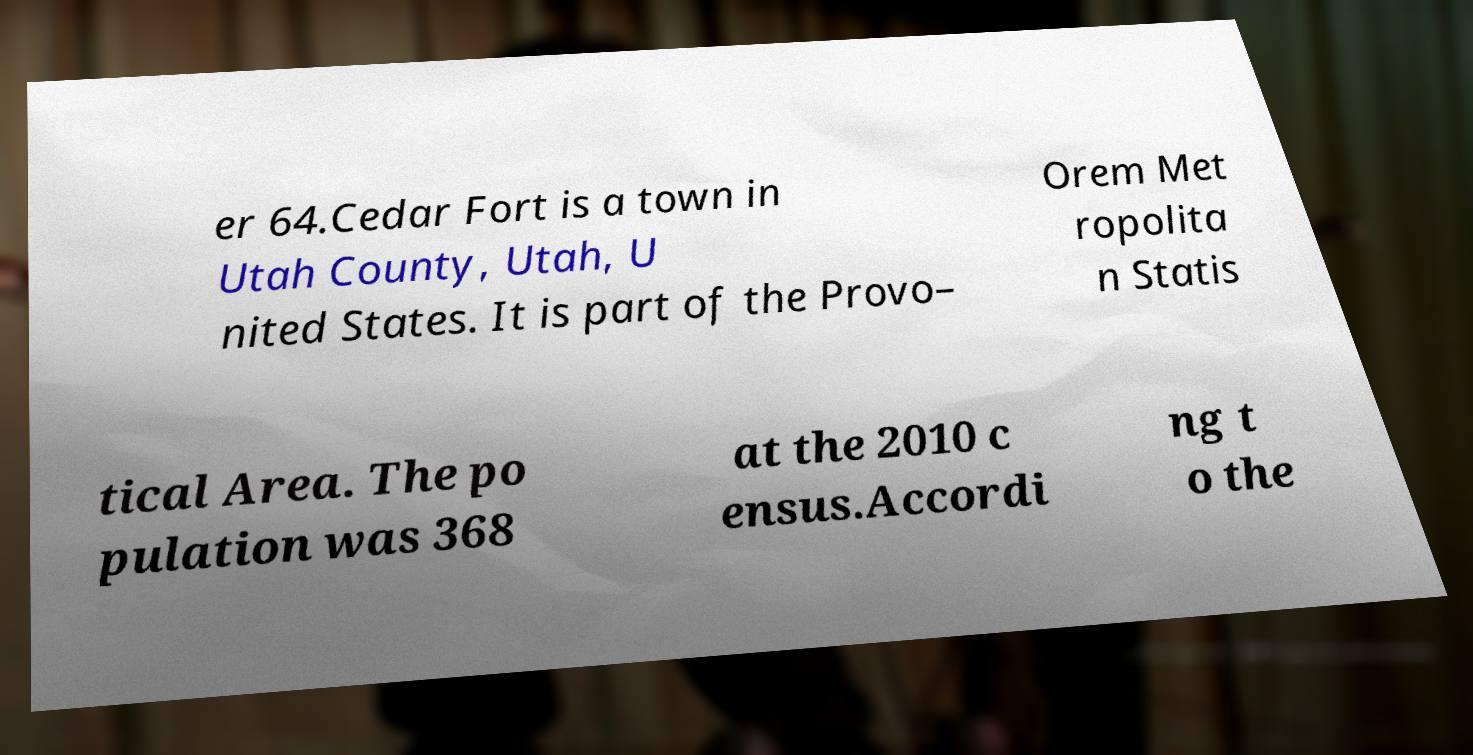There's text embedded in this image that I need extracted. Can you transcribe it verbatim? er 64.Cedar Fort is a town in Utah County, Utah, U nited States. It is part of the Provo– Orem Met ropolita n Statis tical Area. The po pulation was 368 at the 2010 c ensus.Accordi ng t o the 